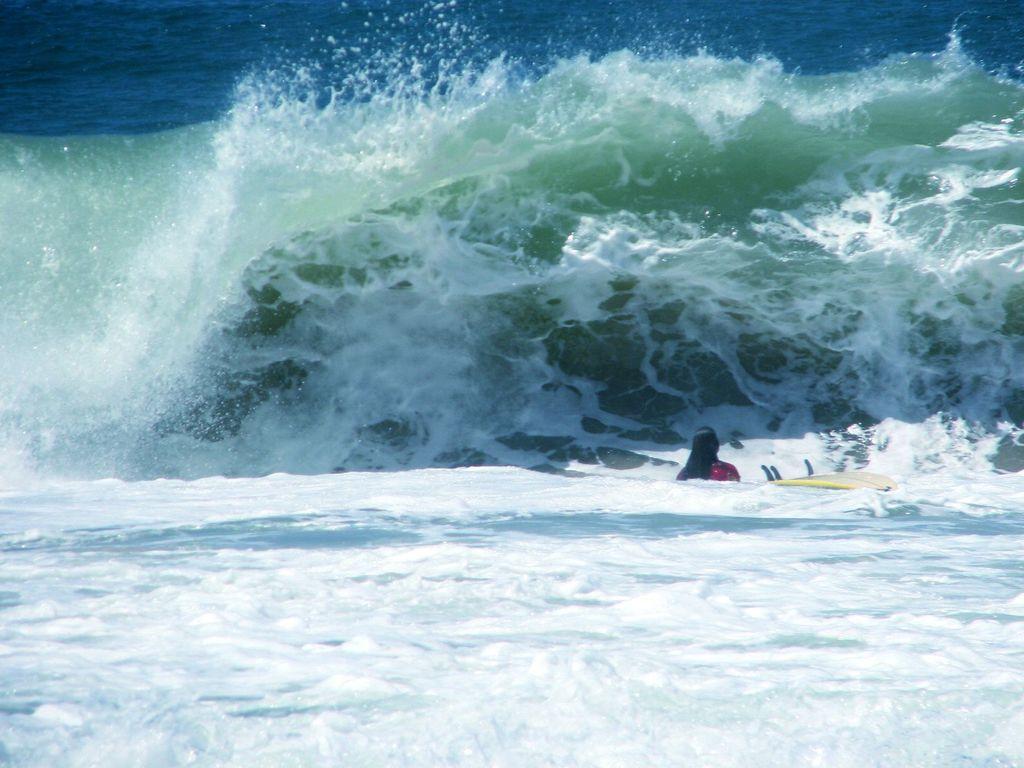How would you summarize this image in a sentence or two? In the picture we can see water with white color tides on it and we can see a person on the surfboard and in the background we can see the water which is blue in color. 